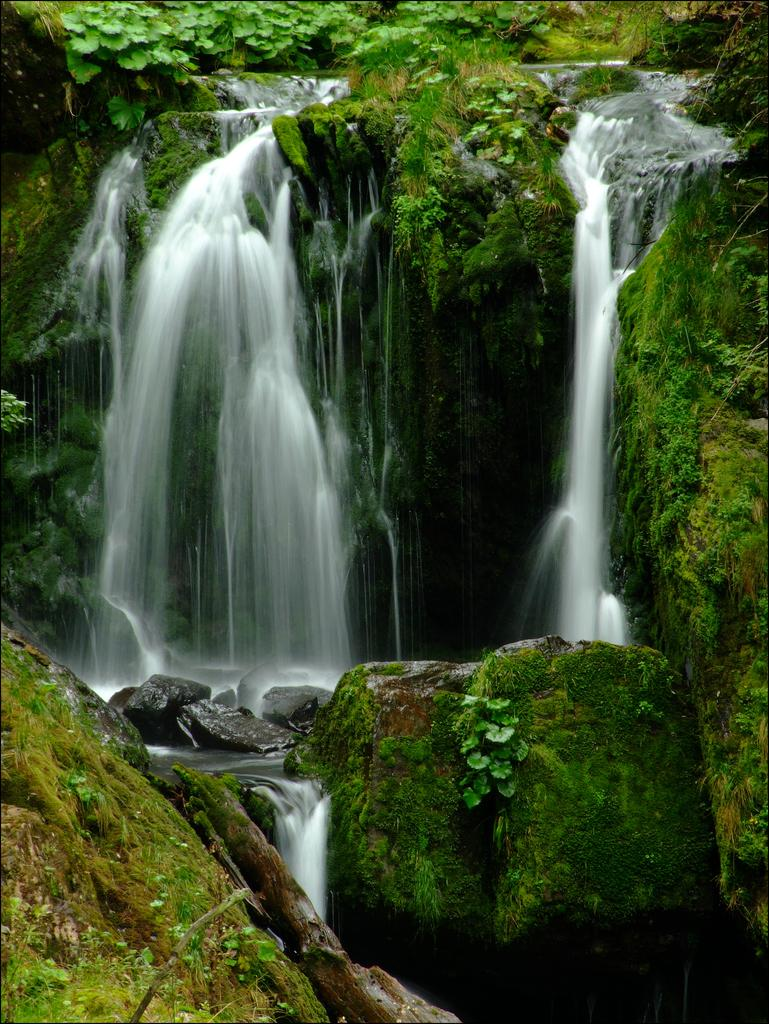What natural feature is the main subject of the image? There is a waterfall in the image. What can be seen on the rocks near the waterfall? Algae is present on the rocks. What type of vegetation is visible in the image? There are plants in the image. What type of canvas is the mother using to paint the park in the image? There is no canvas, mother, or park present in the image; it features a waterfall and plants. 